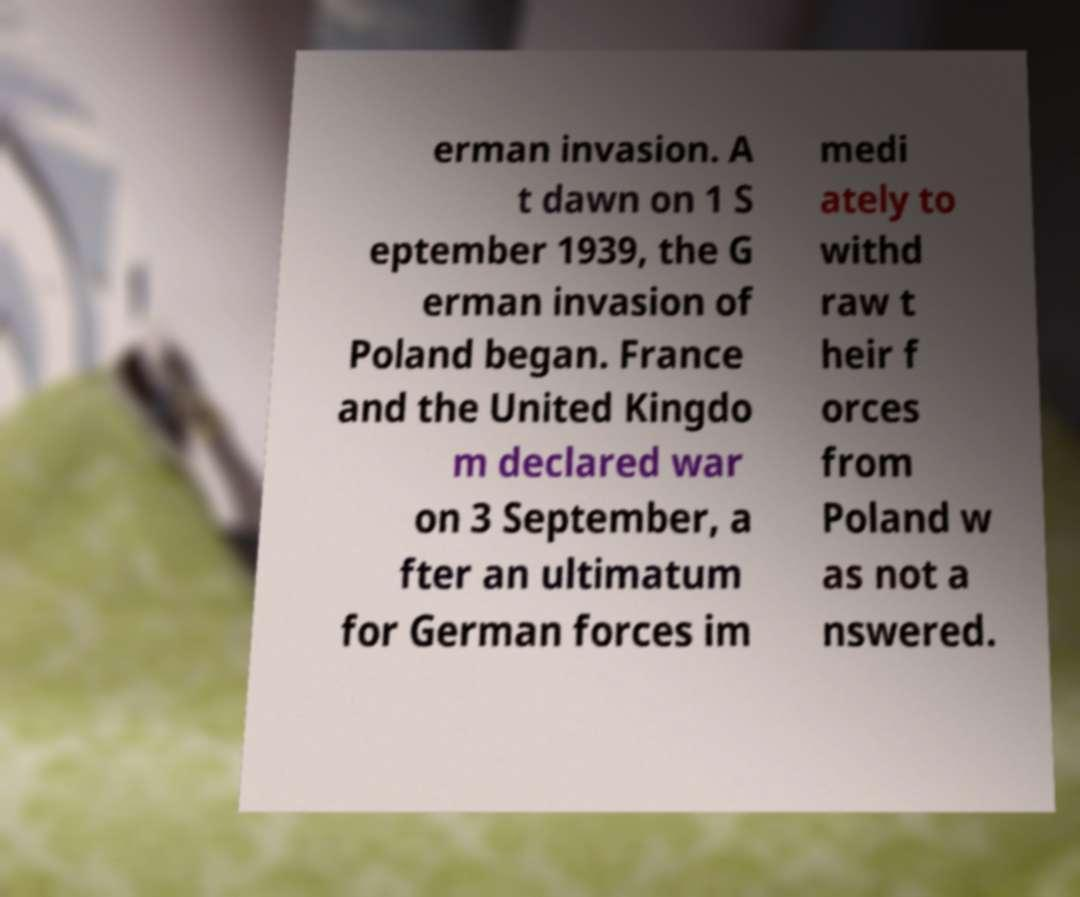Can you read and provide the text displayed in the image?This photo seems to have some interesting text. Can you extract and type it out for me? erman invasion. A t dawn on 1 S eptember 1939, the G erman invasion of Poland began. France and the United Kingdo m declared war on 3 September, a fter an ultimatum for German forces im medi ately to withd raw t heir f orces from Poland w as not a nswered. 